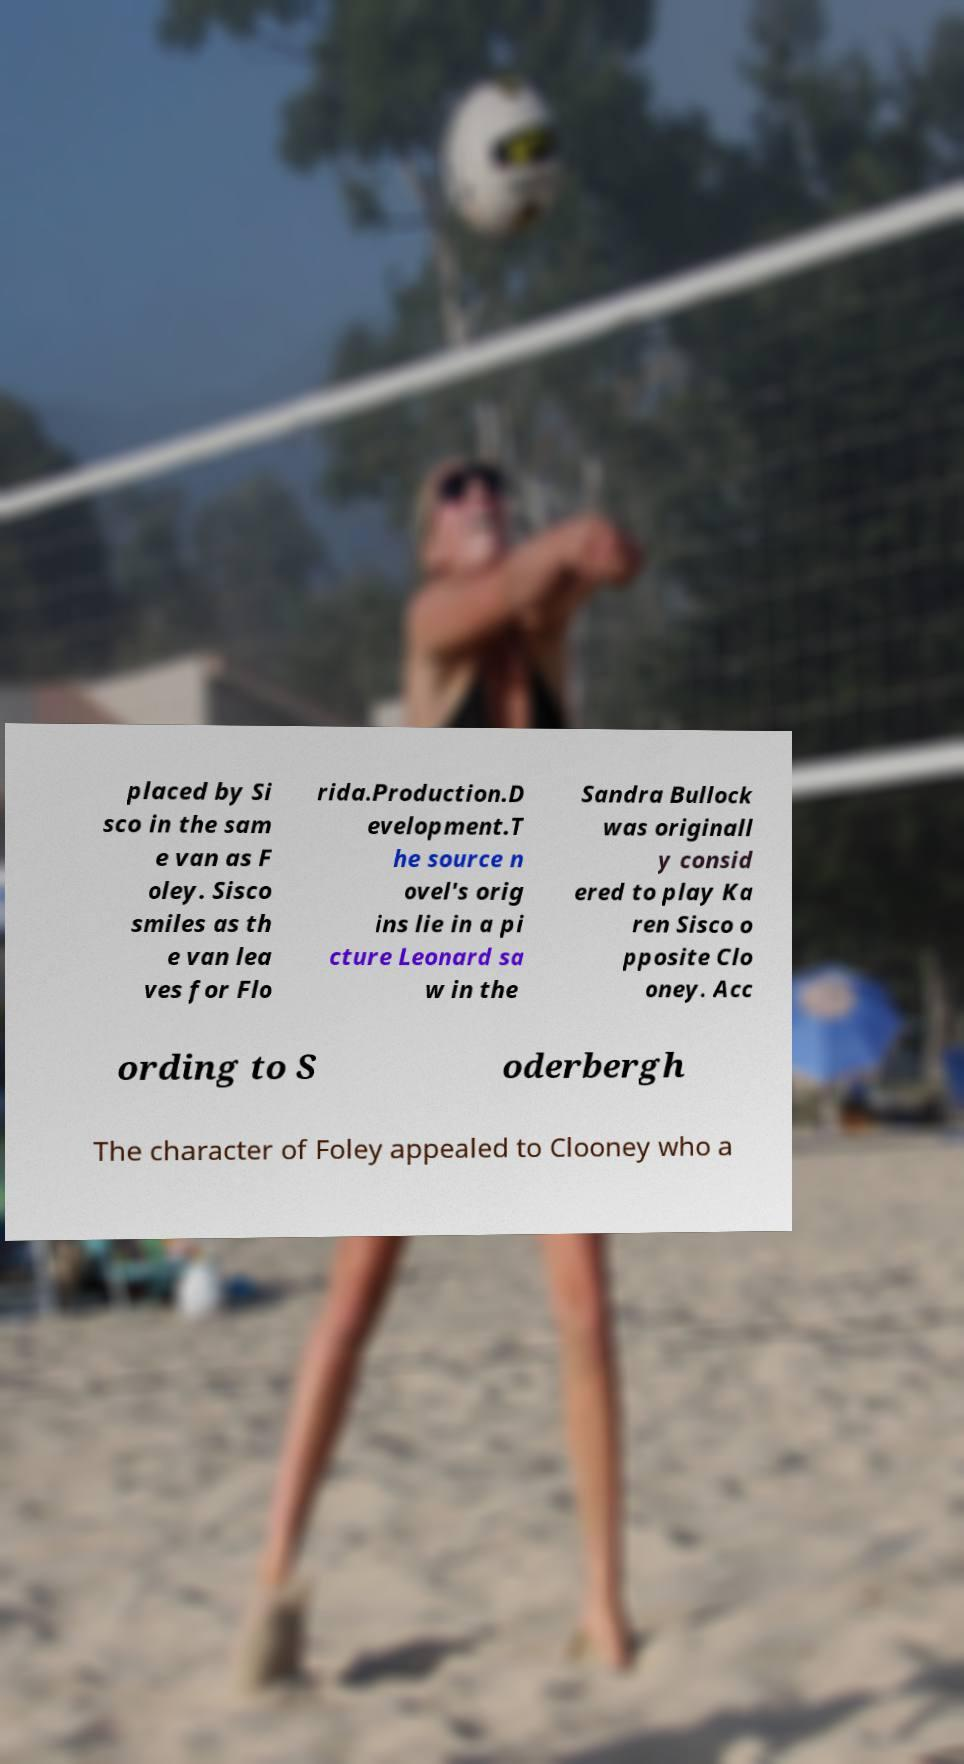Please read and relay the text visible in this image. What does it say? placed by Si sco in the sam e van as F oley. Sisco smiles as th e van lea ves for Flo rida.Production.D evelopment.T he source n ovel's orig ins lie in a pi cture Leonard sa w in the Sandra Bullock was originall y consid ered to play Ka ren Sisco o pposite Clo oney. Acc ording to S oderbergh The character of Foley appealed to Clooney who a 